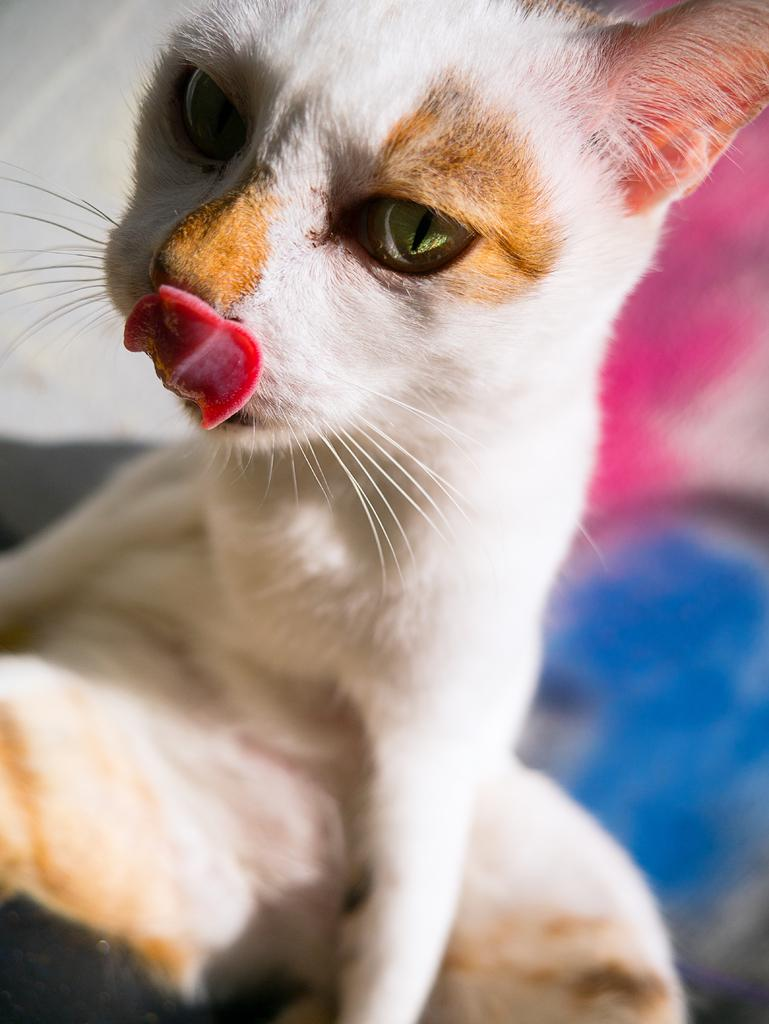What type of animal is in the image? There is a cat in the image. Can you describe the background of the image? The background of the image is blurred. Despite the blur, are there any objects visible in the background? Yes, there are some objects visible in the background, although their specific nature is unclear due to the blur. What type of value can be seen in the image? There is no reference to any value in the image; it features a cat and a blurred background. Is there a light bulb visible in the image? There is no light bulb present in the image. 